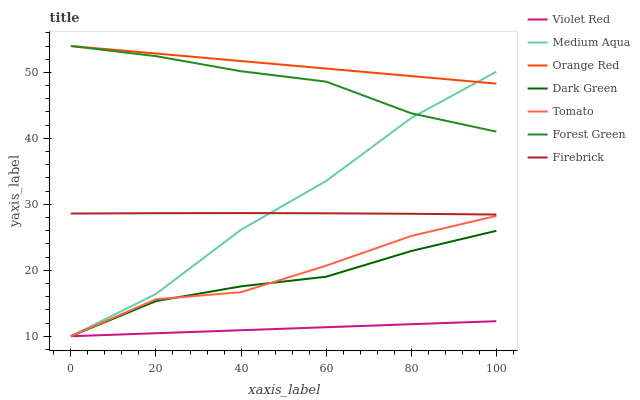Does Firebrick have the minimum area under the curve?
Answer yes or no. No. Does Firebrick have the maximum area under the curve?
Answer yes or no. No. Is Firebrick the smoothest?
Answer yes or no. No. Is Firebrick the roughest?
Answer yes or no. No. Does Firebrick have the lowest value?
Answer yes or no. No. Does Firebrick have the highest value?
Answer yes or no. No. Is Dark Green less than Orange Red?
Answer yes or no. Yes. Is Forest Green greater than Firebrick?
Answer yes or no. Yes. Does Dark Green intersect Orange Red?
Answer yes or no. No. 